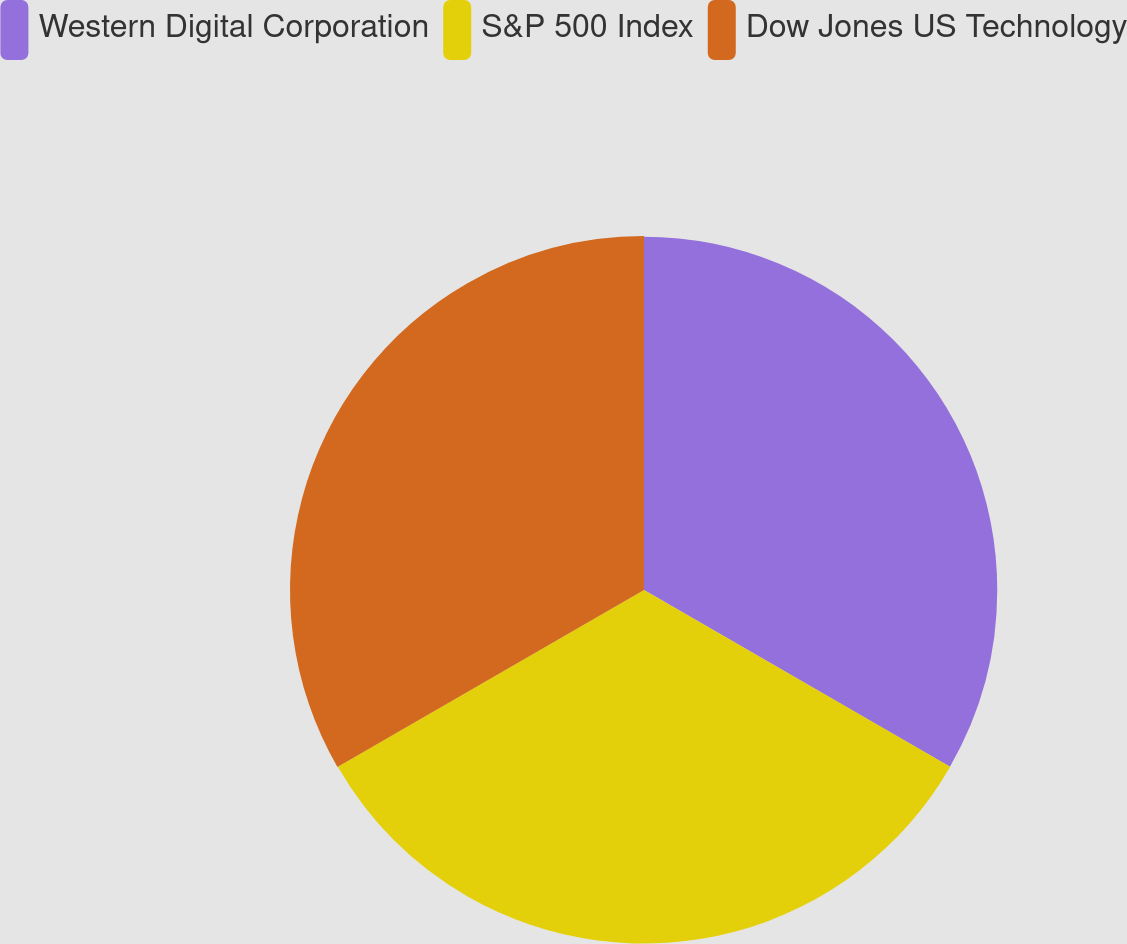<chart> <loc_0><loc_0><loc_500><loc_500><pie_chart><fcel>Western Digital Corporation<fcel>S&P 500 Index<fcel>Dow Jones US Technology<nl><fcel>33.3%<fcel>33.33%<fcel>33.37%<nl></chart> 